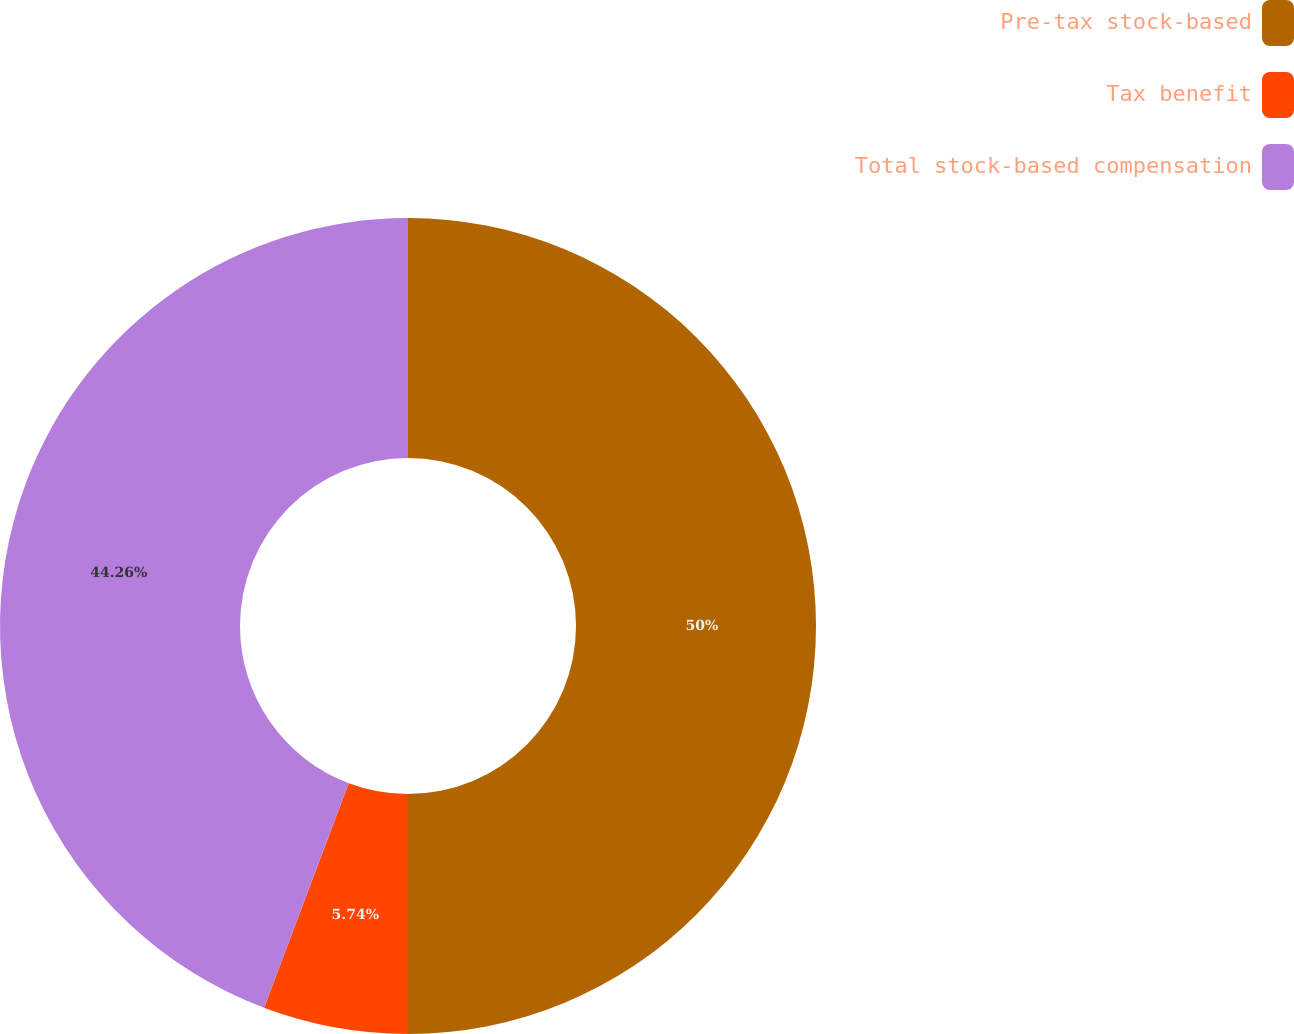<chart> <loc_0><loc_0><loc_500><loc_500><pie_chart><fcel>Pre-tax stock-based<fcel>Tax benefit<fcel>Total stock-based compensation<nl><fcel>50.0%<fcel>5.74%<fcel>44.26%<nl></chart> 